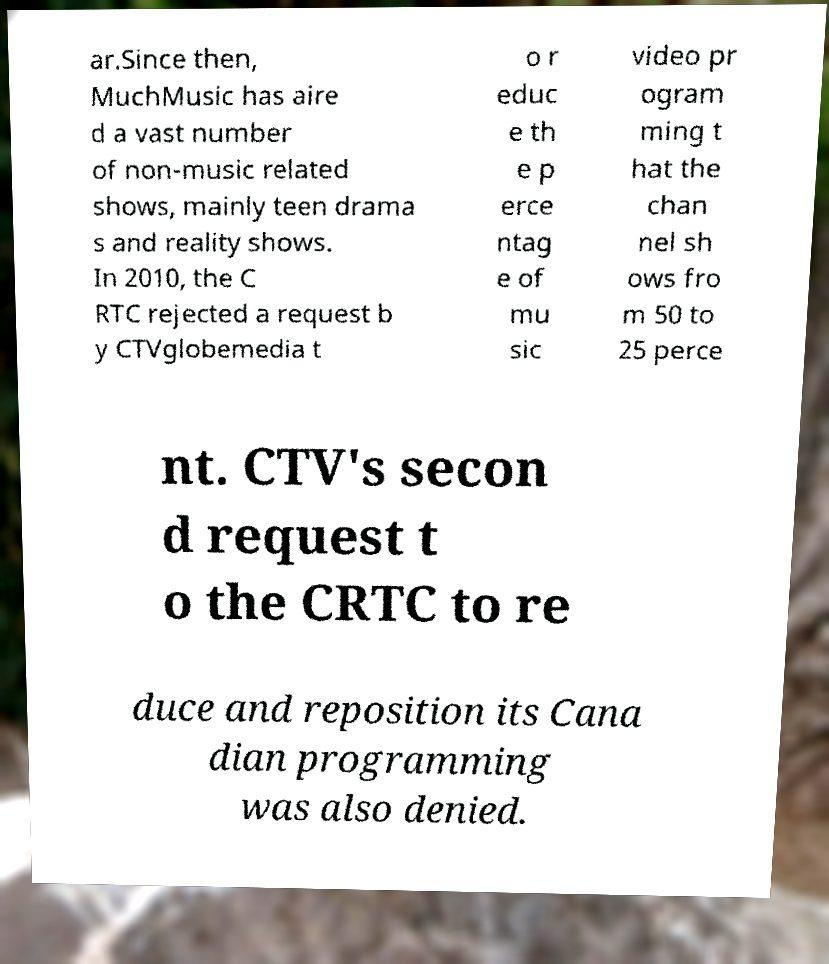For documentation purposes, I need the text within this image transcribed. Could you provide that? ar.Since then, MuchMusic has aire d a vast number of non-music related shows, mainly teen drama s and reality shows. In 2010, the C RTC rejected a request b y CTVglobemedia t o r educ e th e p erce ntag e of mu sic video pr ogram ming t hat the chan nel sh ows fro m 50 to 25 perce nt. CTV's secon d request t o the CRTC to re duce and reposition its Cana dian programming was also denied. 